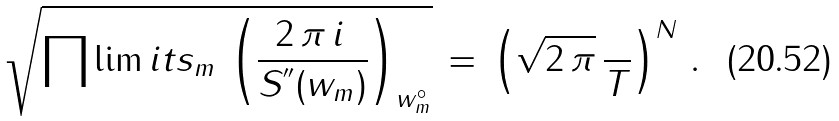Convert formula to latex. <formula><loc_0><loc_0><loc_500><loc_500>\sqrt { \prod \lim i t s _ { m } \, \left ( \frac { 2 \, \pi \, i \, } { S ^ { ^ { \prime \prime } } ( w _ { m } ) } \right ) _ { w ^ { \circ } _ { m } } } \, = \, \left ( \sqrt { 2 \, \pi } \, \frac { } { T } \right ) ^ { N } \, .</formula> 